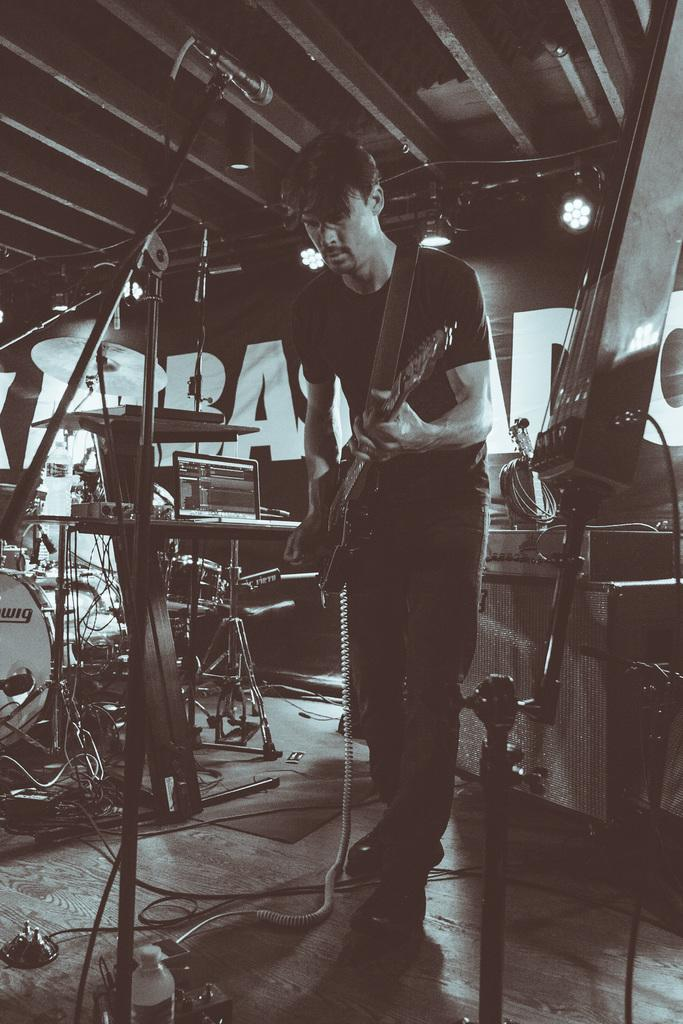Who is present in the image? There is a man in the image. What is the man holding in the image? The man is holding a guitar. What other musical equipment can be seen in the image? There is a microphone on the floor and other musical instruments in the image. What electronic device is visible in the image? There is a laptop in the image. What type of key is used to unlock the snow in the image? There is no key or snow present in the image. 